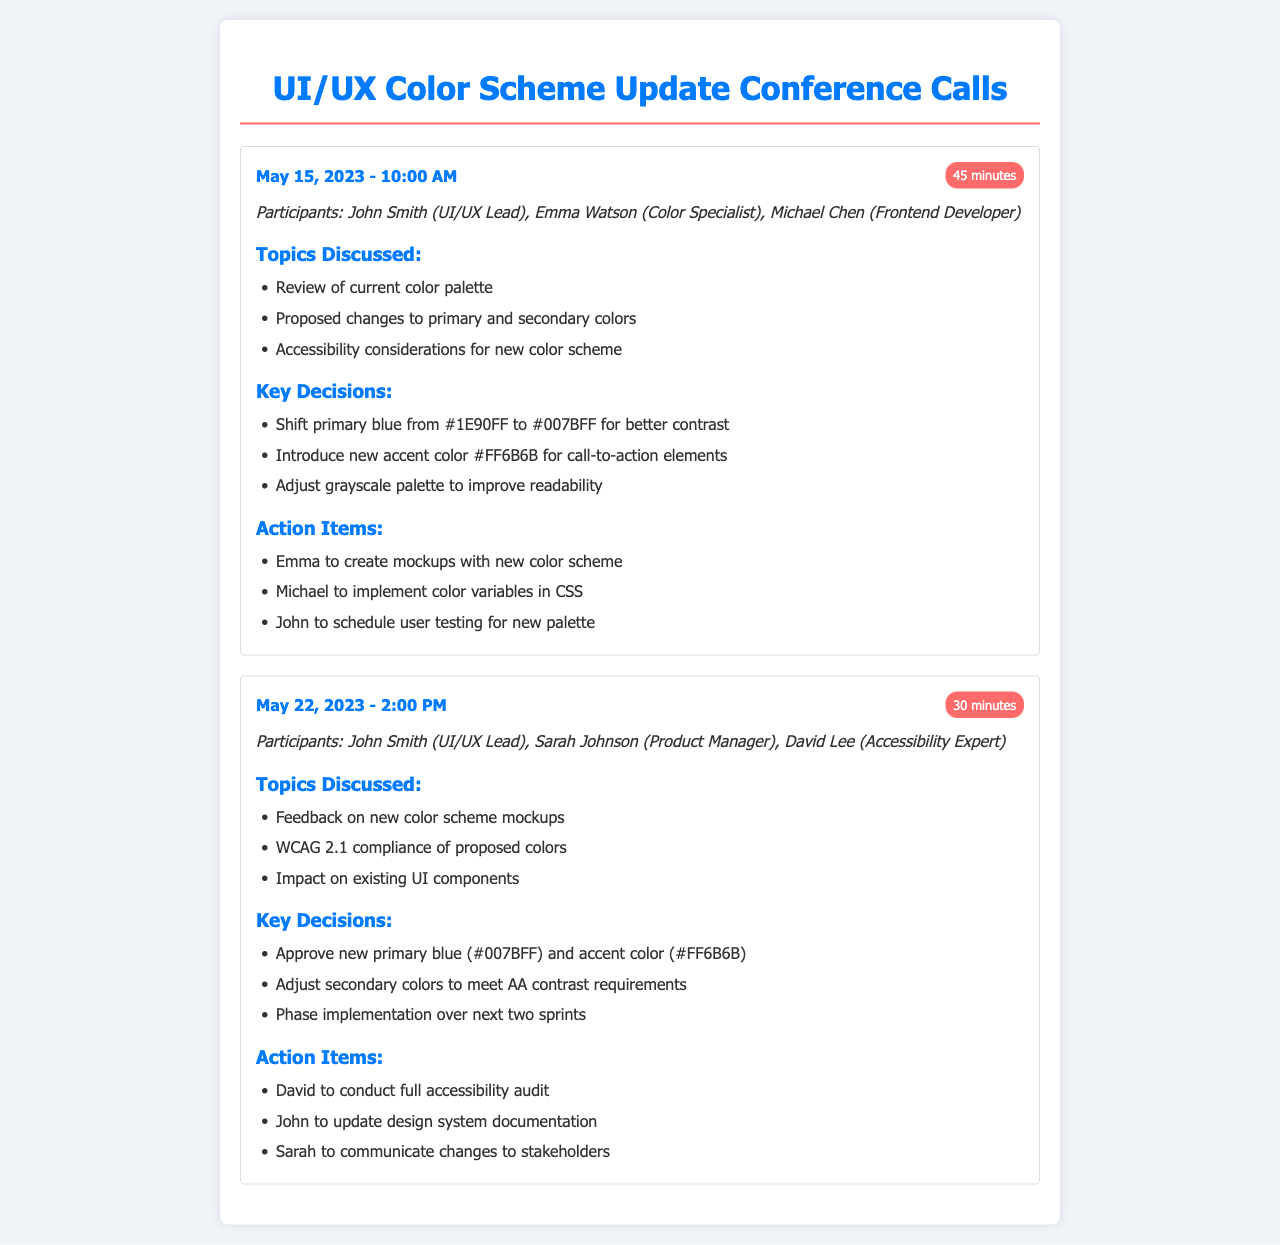what date was the first conference call? The date of the first conference call is explicitly mentioned in the document.
Answer: May 15, 2023 who participated in the second call? The document lists the participants of the second call in a specific section.
Answer: John Smith, Sarah Johnson, David Lee what was the duration of the first call? The duration of the first call is stated in the call record section.
Answer: 45 minutes what color was shifted to improve contrast? The key decision regarding the color change is clearly highlighted in the document.
Answer: primary blue how many action items were listed in the first call? The number of action items in the first call can be counted from the corresponding section in the document.
Answer: 3 what compliance standard was discussed in the second call? The compliance standard mentioned in the topics discussed section relates to accessibility.
Answer: WCAG 2.1 which new accent color was introduced? The document specifies the new accent color as a key decision.
Answer: #FF6B6B what was the focus of the first call? The topics discussed in the first call provide an overview of its focus.
Answer: color palette how many conference calls are recorded in the document? The total number of call records is determined by counting the distinct entries in the document.
Answer: 2 